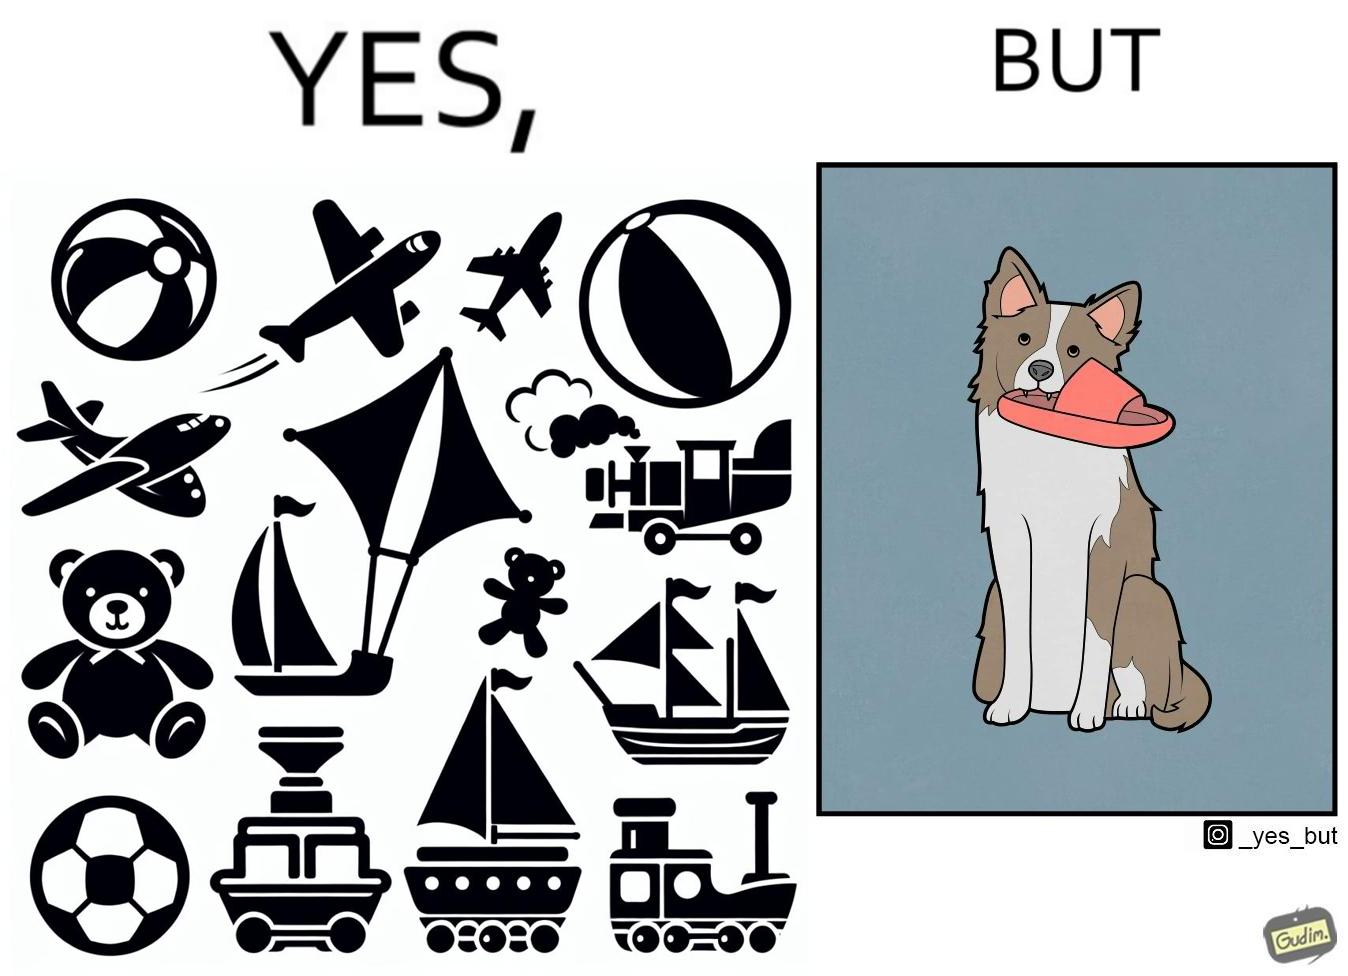Provide a description of this image. The image is ironical, as even though the dog owner has bought toys for the dog, the dog is playing with a slipper in its mouth. 